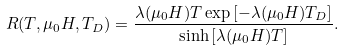Convert formula to latex. <formula><loc_0><loc_0><loc_500><loc_500>R ( T , \mu _ { 0 } H , T _ { D } ) = \frac { \lambda ( \mu _ { 0 } H ) T \exp { [ - \lambda ( \mu _ { 0 } H ) T _ { D } ] } } { \sinh { [ \lambda ( \mu _ { 0 } H ) T ] } } . \\</formula> 